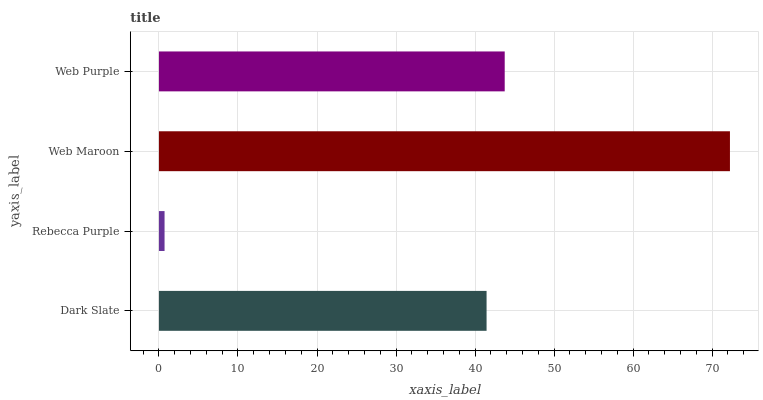Is Rebecca Purple the minimum?
Answer yes or no. Yes. Is Web Maroon the maximum?
Answer yes or no. Yes. Is Web Maroon the minimum?
Answer yes or no. No. Is Rebecca Purple the maximum?
Answer yes or no. No. Is Web Maroon greater than Rebecca Purple?
Answer yes or no. Yes. Is Rebecca Purple less than Web Maroon?
Answer yes or no. Yes. Is Rebecca Purple greater than Web Maroon?
Answer yes or no. No. Is Web Maroon less than Rebecca Purple?
Answer yes or no. No. Is Web Purple the high median?
Answer yes or no. Yes. Is Dark Slate the low median?
Answer yes or no. Yes. Is Web Maroon the high median?
Answer yes or no. No. Is Web Maroon the low median?
Answer yes or no. No. 